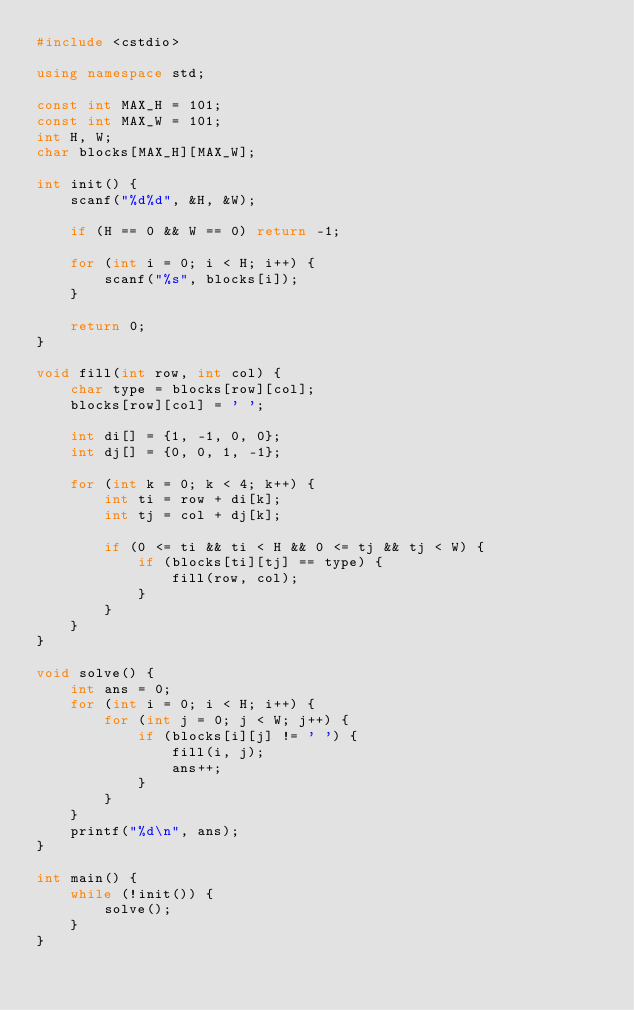<code> <loc_0><loc_0><loc_500><loc_500><_C++_>#include <cstdio>

using namespace std;

const int MAX_H = 101;
const int MAX_W = 101;
int H, W;
char blocks[MAX_H][MAX_W];

int init() {
	scanf("%d%d", &H, &W);

	if (H == 0 && W == 0) return -1;
	
	for (int i = 0; i < H; i++) {
		scanf("%s", blocks[i]);
	}
	
	return 0;
}

void fill(int row, int col) {
	char type = blocks[row][col];
	blocks[row][col] = ' ';
	
	int di[] = {1, -1, 0, 0};
	int dj[] = {0, 0, 1, -1};
	
	for (int k = 0; k < 4; k++) {
		int ti = row + di[k];
		int tj = col + dj[k];
		
		if (0 <= ti && ti < H && 0 <= tj && tj < W) {
			if (blocks[ti][tj] == type) {
				fill(row, col);
			}
		}
	}
}

void solve() {
	int ans = 0;
	for (int i = 0; i < H; i++) {
		for (int j = 0; j < W; j++) {
			if (blocks[i][j] != ' ') {
				fill(i, j);
				ans++;
			}
		}
	}
	printf("%d\n", ans);
}

int main() {
	while (!init()) {
		solve();
	}
}</code> 